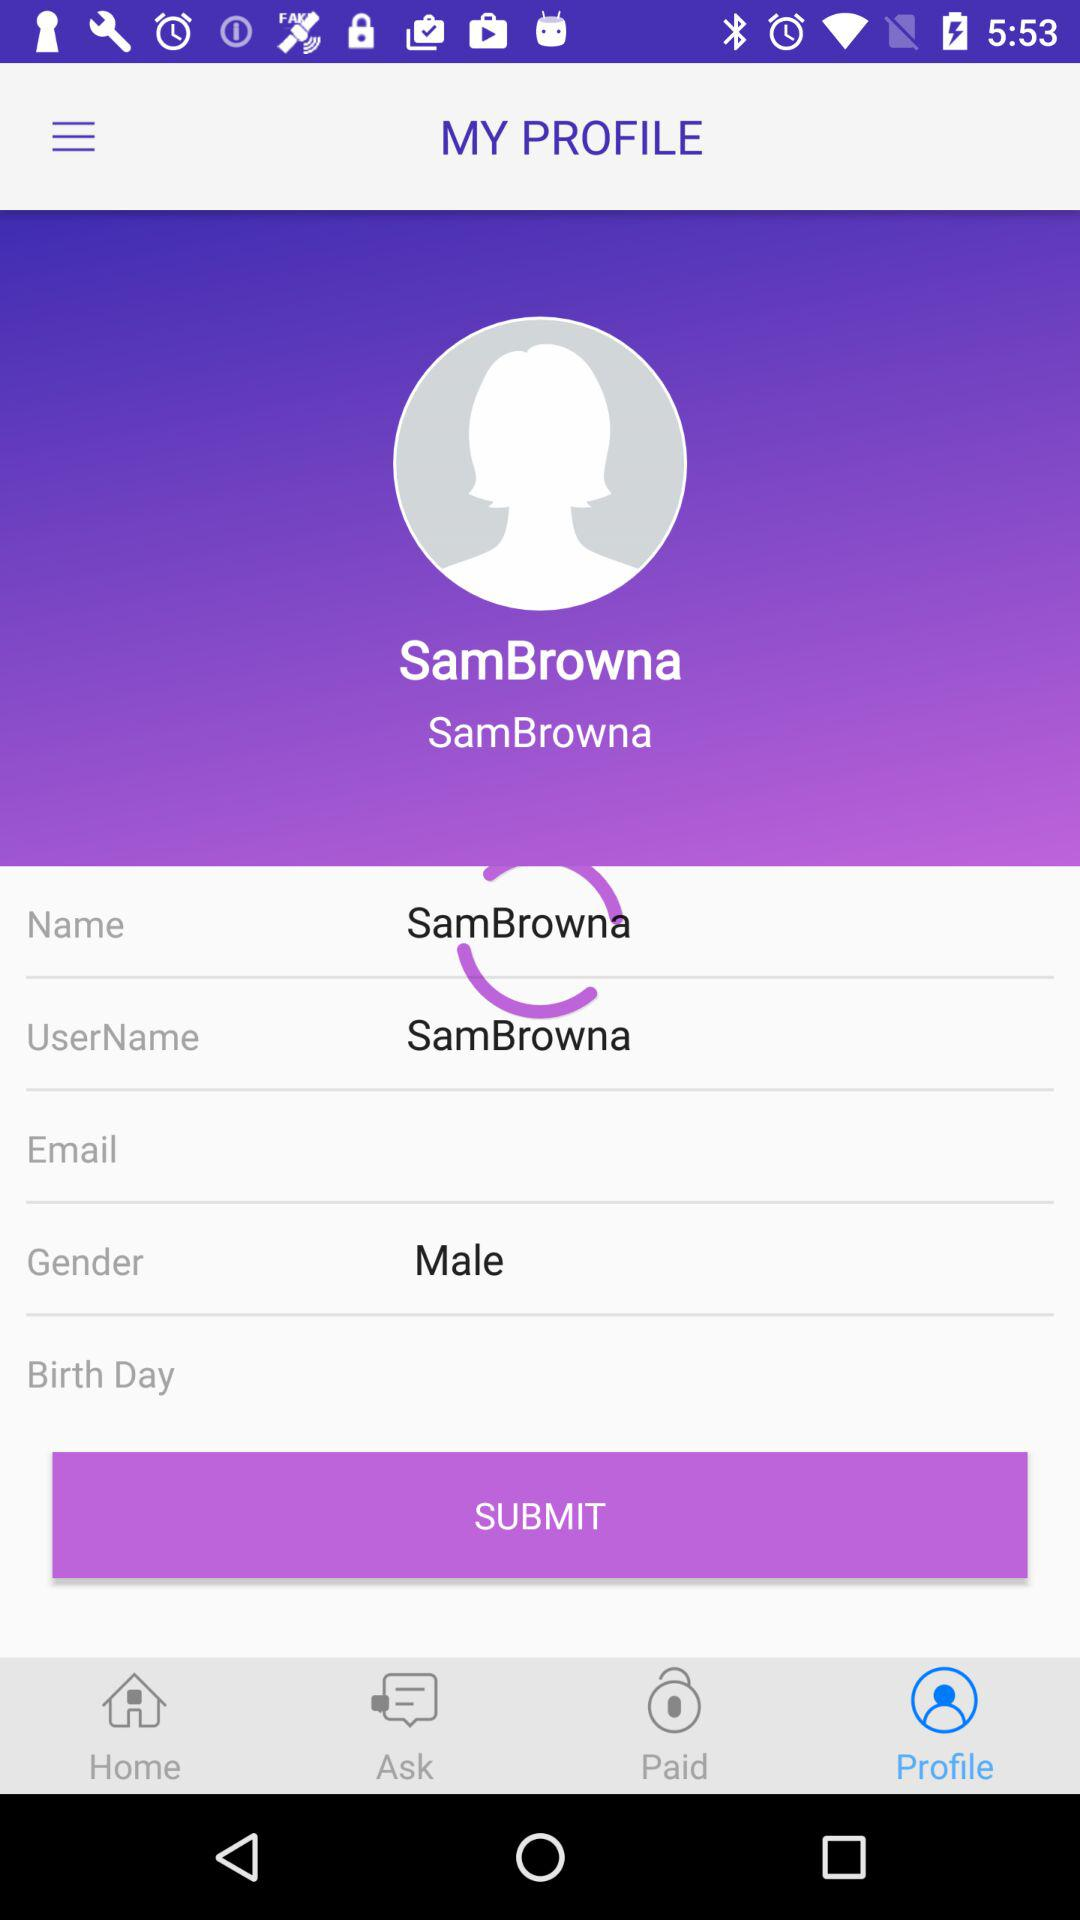What is the name? The name is Sam Browna. 